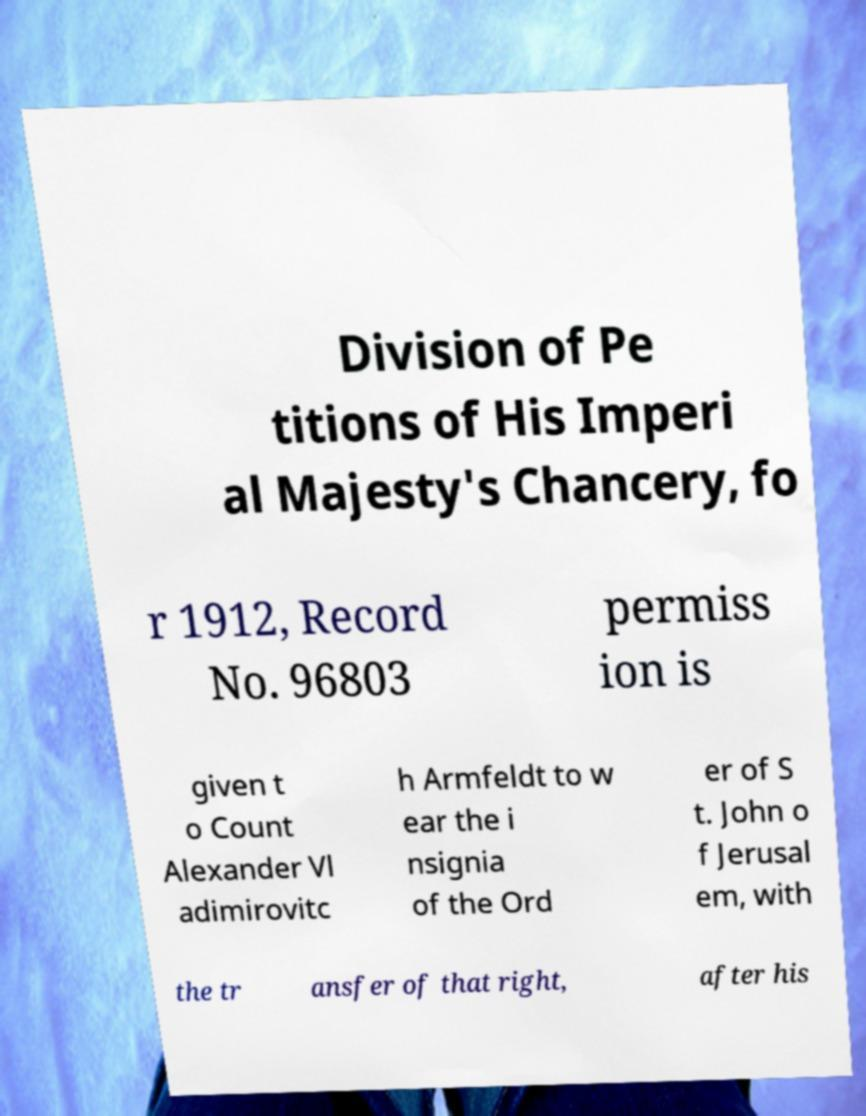Could you assist in decoding the text presented in this image and type it out clearly? Division of Pe titions of His Imperi al Majesty's Chancery, fo r 1912, Record No. 96803 permiss ion is given t o Count Alexander Vl adimirovitc h Armfeldt to w ear the i nsignia of the Ord er of S t. John o f Jerusal em, with the tr ansfer of that right, after his 